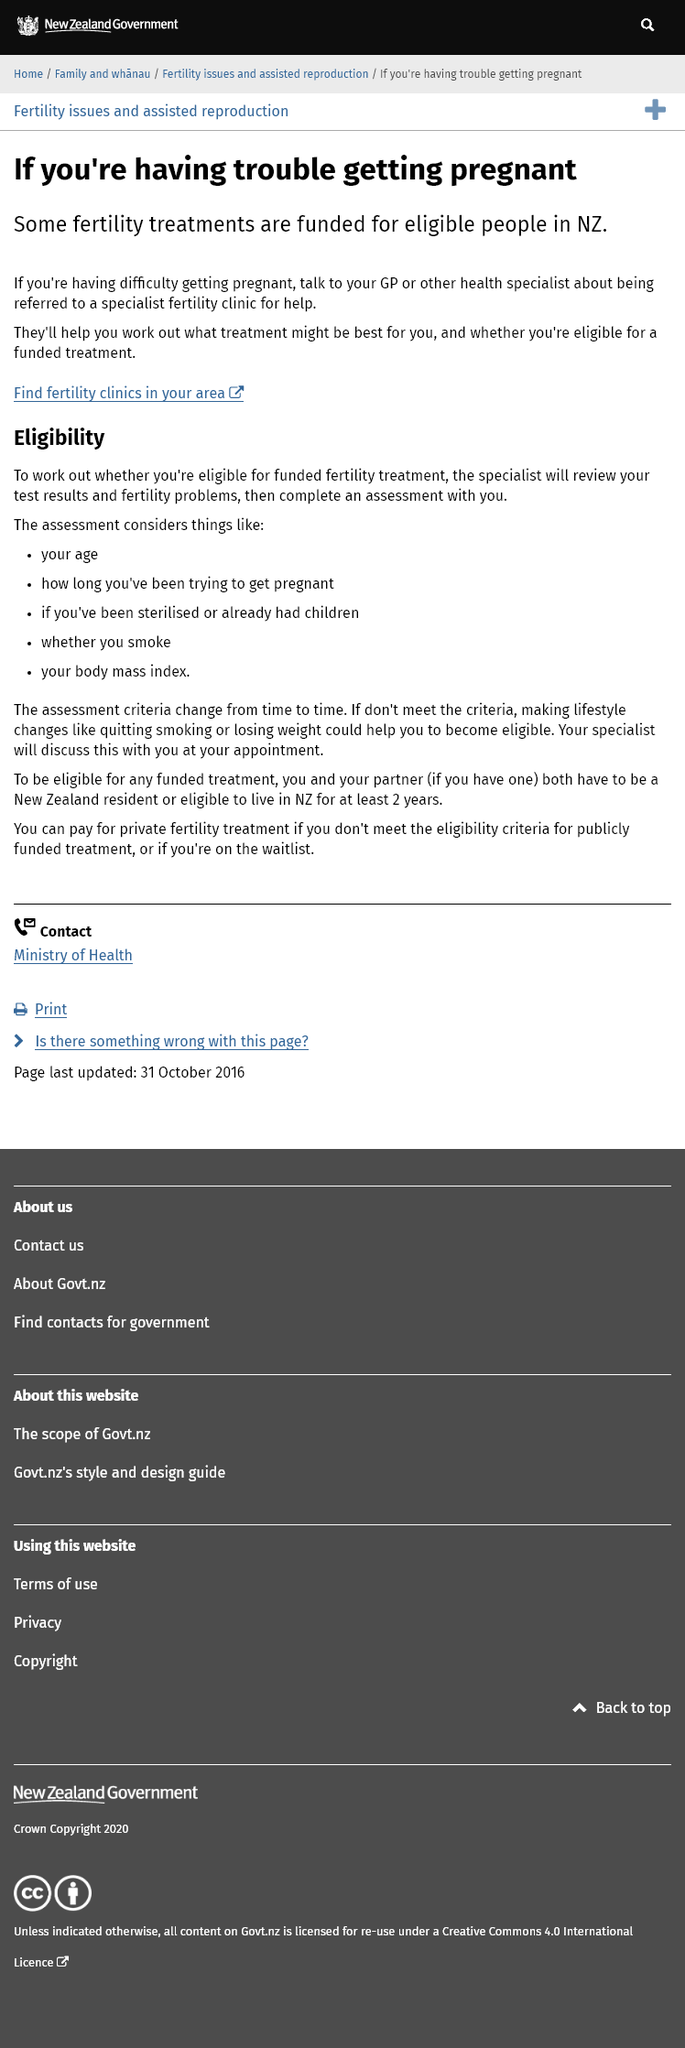List a handful of essential elements in this visual. It is recommended that an individual seeking specialized fertility treatment should consult their General Practitioner or a health specialist for referral to a reputable fertility clinic. In New Zealand, some fertility treatments are funded for eligible individuals, but not everyone is covered by these treatments. Eligibility assessment considers factors such as age, smoking status, body mass index, sterilisation or childbirth history, and duration of infertility treatment. 